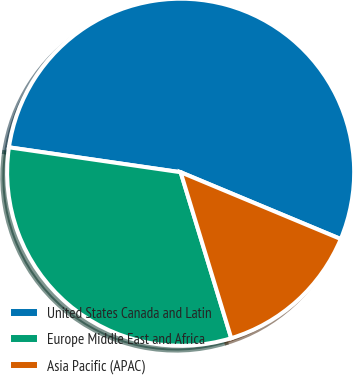Convert chart to OTSL. <chart><loc_0><loc_0><loc_500><loc_500><pie_chart><fcel>United States Canada and Latin<fcel>Europe Middle East and Africa<fcel>Asia Pacific (APAC)<nl><fcel>54.0%<fcel>32.0%<fcel>14.0%<nl></chart> 